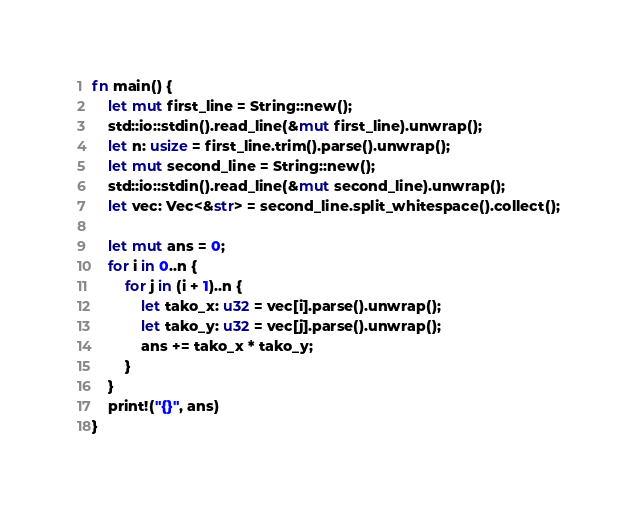Convert code to text. <code><loc_0><loc_0><loc_500><loc_500><_Rust_>fn main() {
    let mut first_line = String::new();
    std::io::stdin().read_line(&mut first_line).unwrap();
    let n: usize = first_line.trim().parse().unwrap();
    let mut second_line = String::new();
    std::io::stdin().read_line(&mut second_line).unwrap();
    let vec: Vec<&str> = second_line.split_whitespace().collect();

    let mut ans = 0;
    for i in 0..n {
        for j in (i + 1)..n {
            let tako_x: u32 = vec[i].parse().unwrap();
            let tako_y: u32 = vec[j].parse().unwrap();
            ans += tako_x * tako_y;
        }
    }
    print!("{}", ans)
}
</code> 